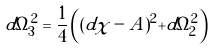<formula> <loc_0><loc_0><loc_500><loc_500>d \Omega _ { 3 } ^ { 2 } = \frac { 1 } { 4 } \left ( ( d \chi - A ) ^ { 2 } + d \Omega _ { 2 } ^ { 2 } \right )</formula> 